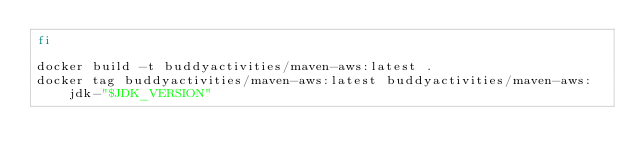<code> <loc_0><loc_0><loc_500><loc_500><_Bash_>fi

docker build -t buddyactivities/maven-aws:latest .
docker tag buddyactivities/maven-aws:latest buddyactivities/maven-aws:jdk-"$JDK_VERSION"
</code> 